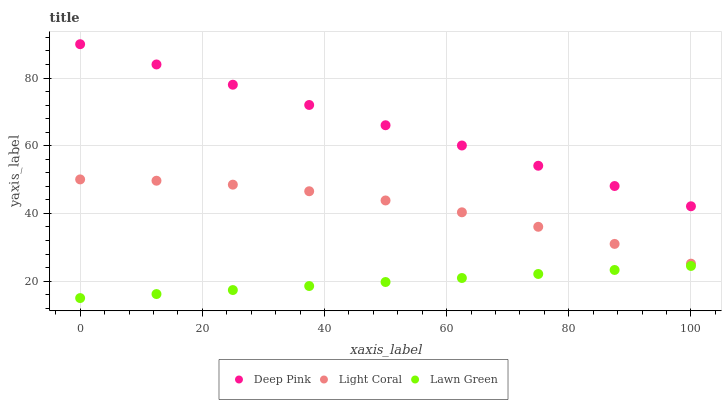Does Lawn Green have the minimum area under the curve?
Answer yes or no. Yes. Does Deep Pink have the maximum area under the curve?
Answer yes or no. Yes. Does Deep Pink have the minimum area under the curve?
Answer yes or no. No. Does Lawn Green have the maximum area under the curve?
Answer yes or no. No. Is Deep Pink the smoothest?
Answer yes or no. Yes. Is Light Coral the roughest?
Answer yes or no. Yes. Is Lawn Green the smoothest?
Answer yes or no. No. Is Lawn Green the roughest?
Answer yes or no. No. Does Lawn Green have the lowest value?
Answer yes or no. Yes. Does Deep Pink have the lowest value?
Answer yes or no. No. Does Deep Pink have the highest value?
Answer yes or no. Yes. Does Lawn Green have the highest value?
Answer yes or no. No. Is Lawn Green less than Light Coral?
Answer yes or no. Yes. Is Light Coral greater than Lawn Green?
Answer yes or no. Yes. Does Lawn Green intersect Light Coral?
Answer yes or no. No. 